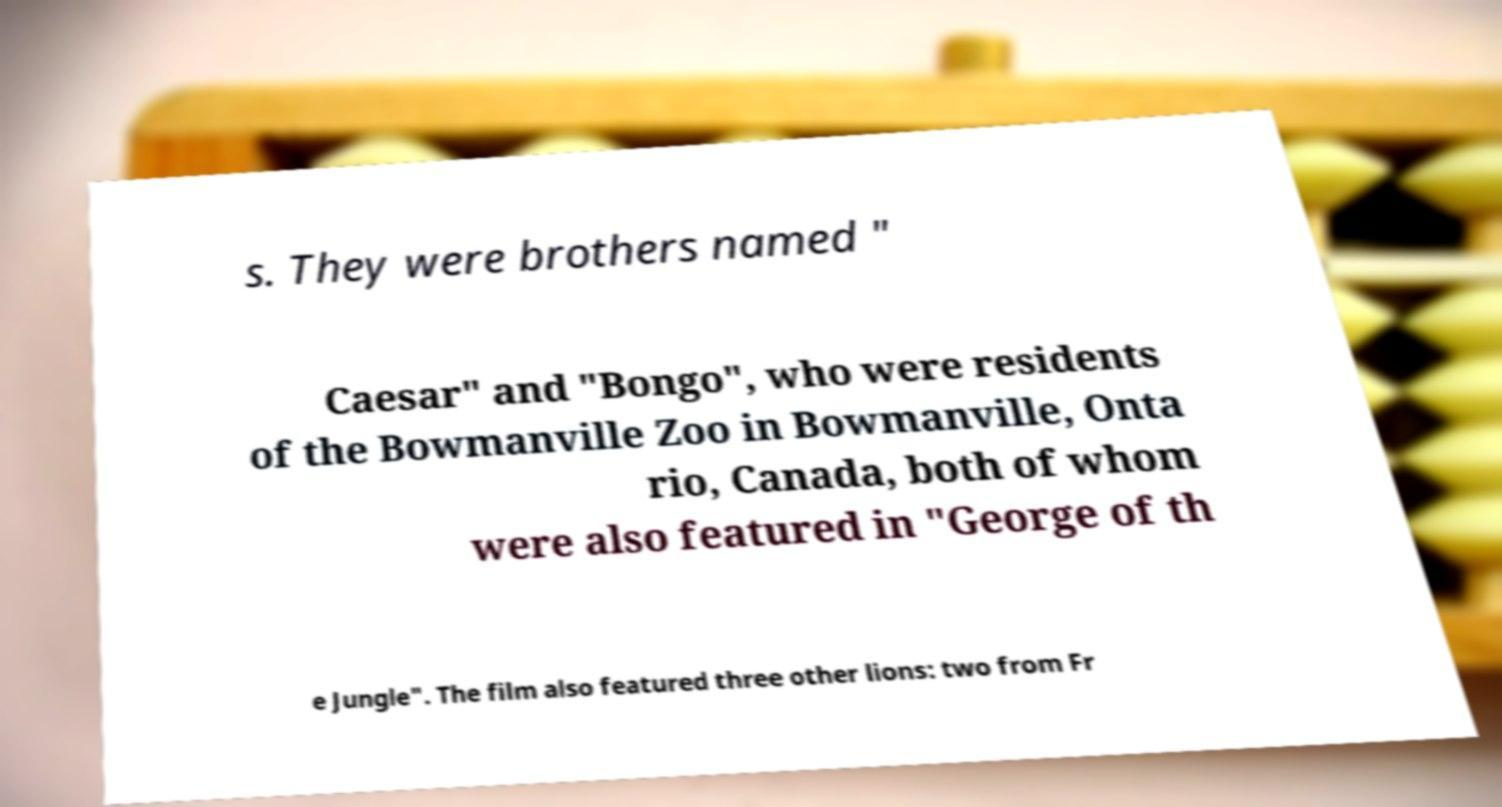Please identify and transcribe the text found in this image. s. They were brothers named " Caesar" and "Bongo", who were residents of the Bowmanville Zoo in Bowmanville, Onta rio, Canada, both of whom were also featured in "George of th e Jungle". The film also featured three other lions: two from Fr 